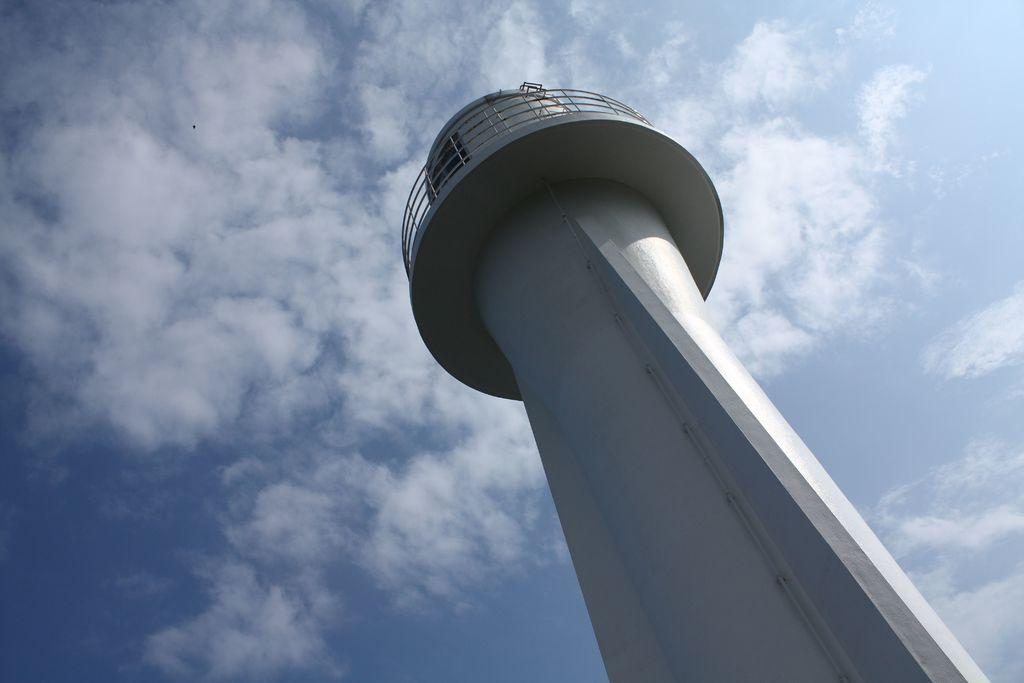What type of building is depicted in the image? There is a building in the shape of a tower in the image. What is the weather like in the image? The sky is sunny in the image. What color is the tower painted? The tower is painted white. How many bags of power can be seen in the image? There are no bags or power present in the image; it features a tower-shaped building and a sunny sky. 